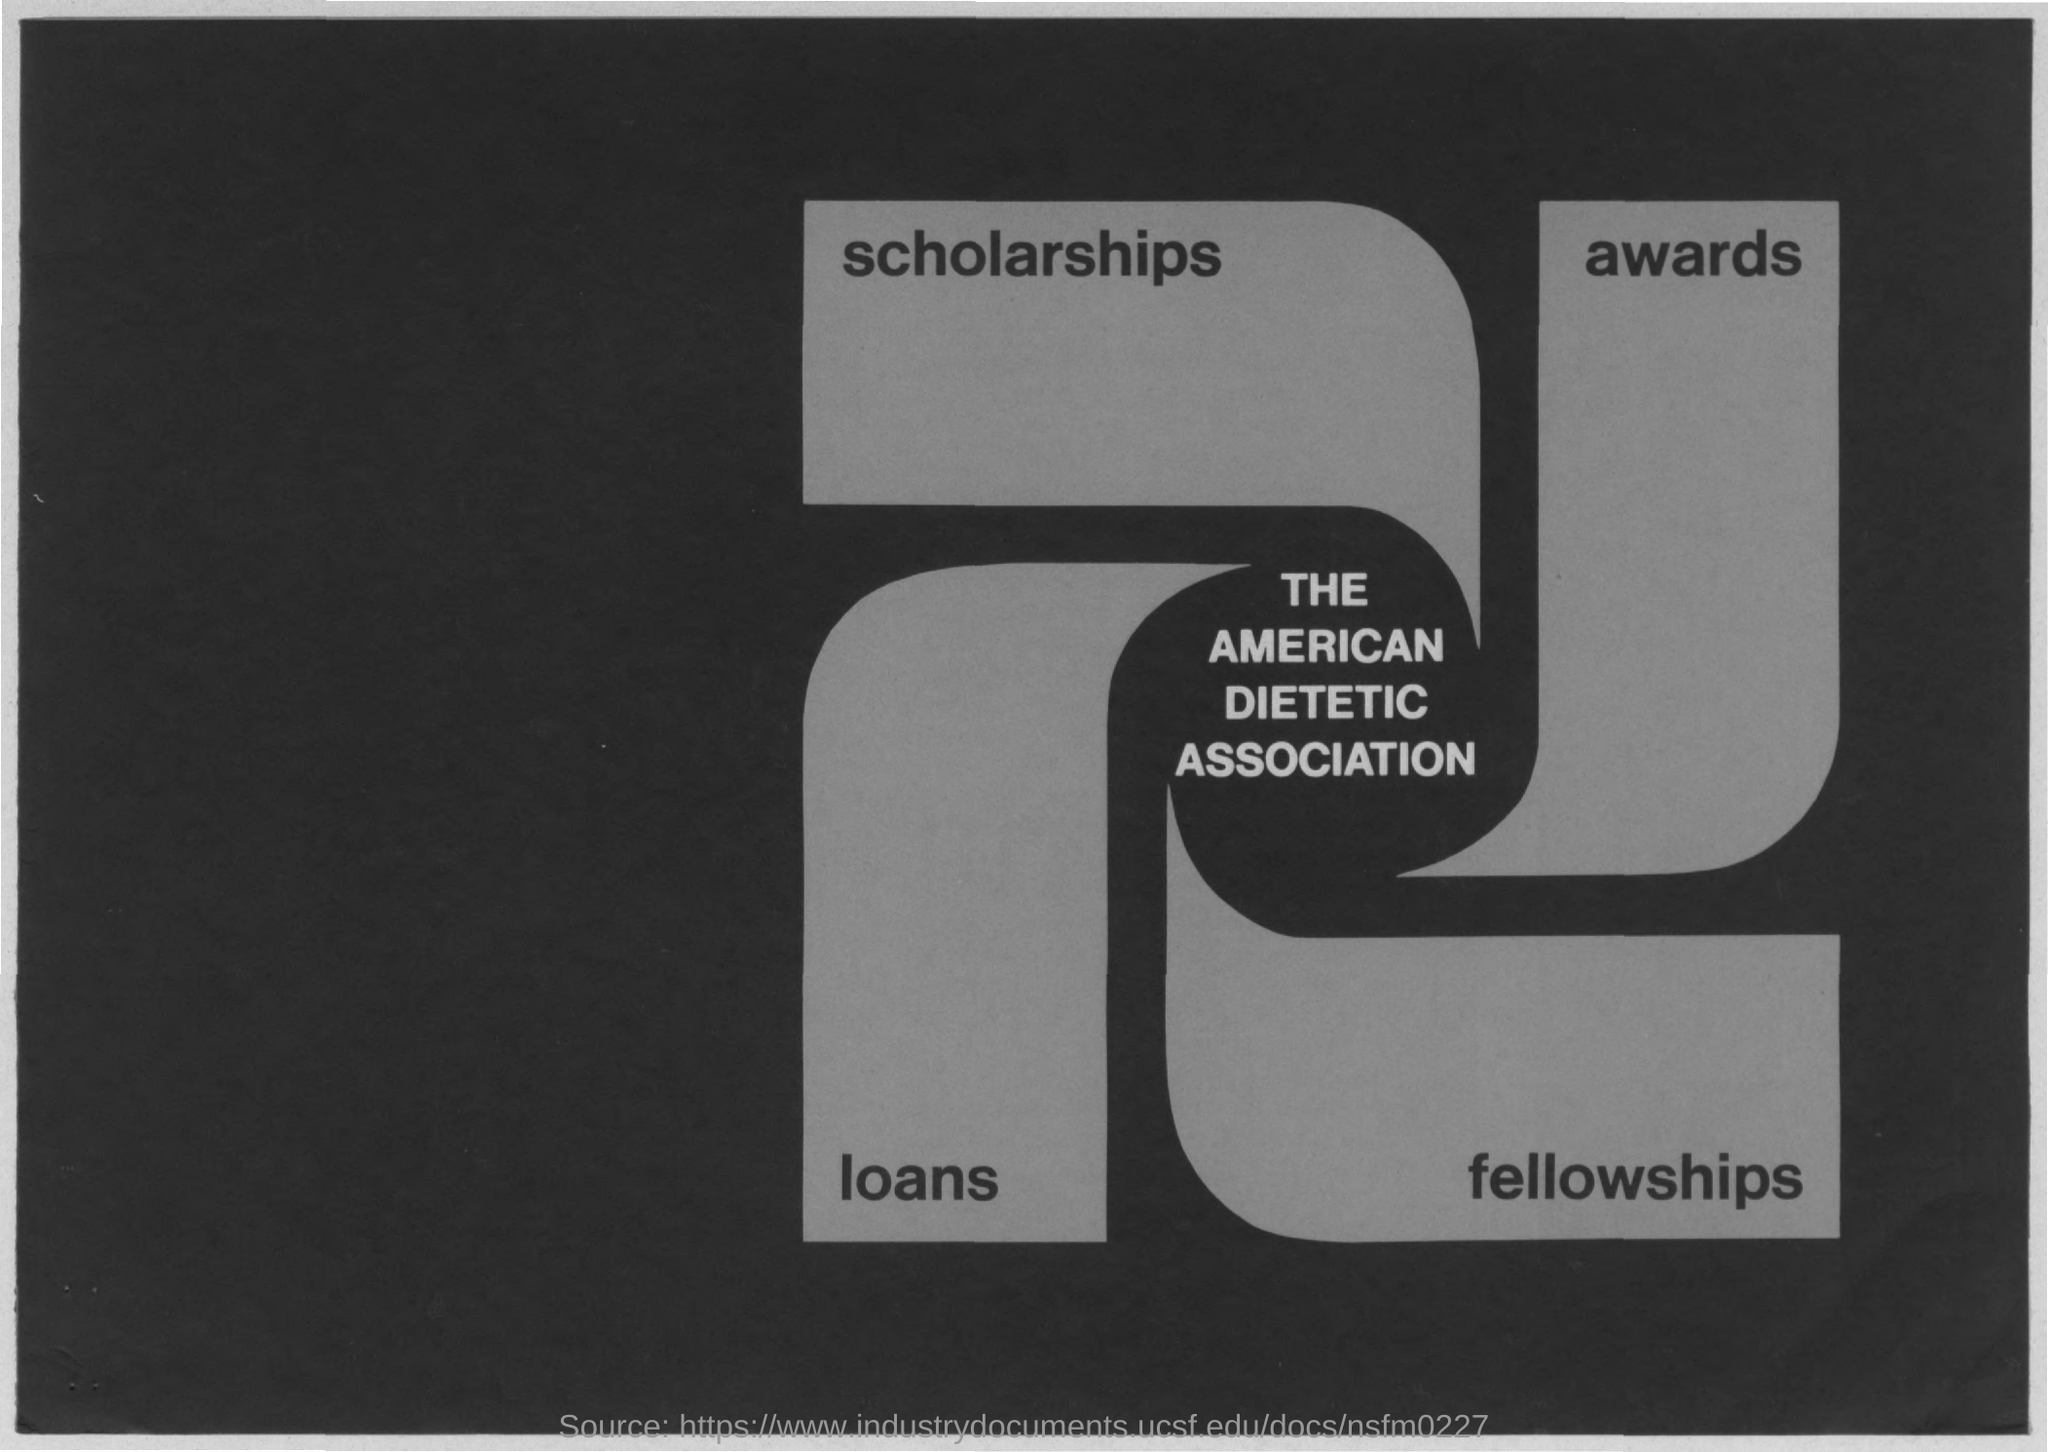What is written in the center of the image?
Keep it short and to the point. The american dietetic association. What is written in the top right of the image?
Give a very brief answer. Awards. What is written in the top left of the image?
Provide a succinct answer. Scholarships. What is written in the bottom right of the image?
Provide a succinct answer. Fellowships. What is written in the bottom left of the image?
Provide a succinct answer. Loans. 